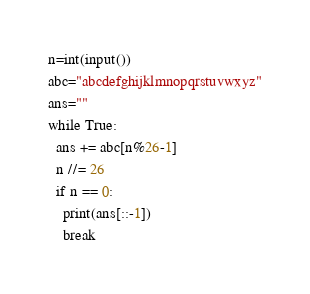Convert code to text. <code><loc_0><loc_0><loc_500><loc_500><_Python_>n=int(input())
abc="abcdefghijklmnopqrstuvwxyz"
ans=""
while True:
  ans += abc[n%26-1]
  n //= 26
  if n == 0:
    print(ans[::-1])
    break</code> 